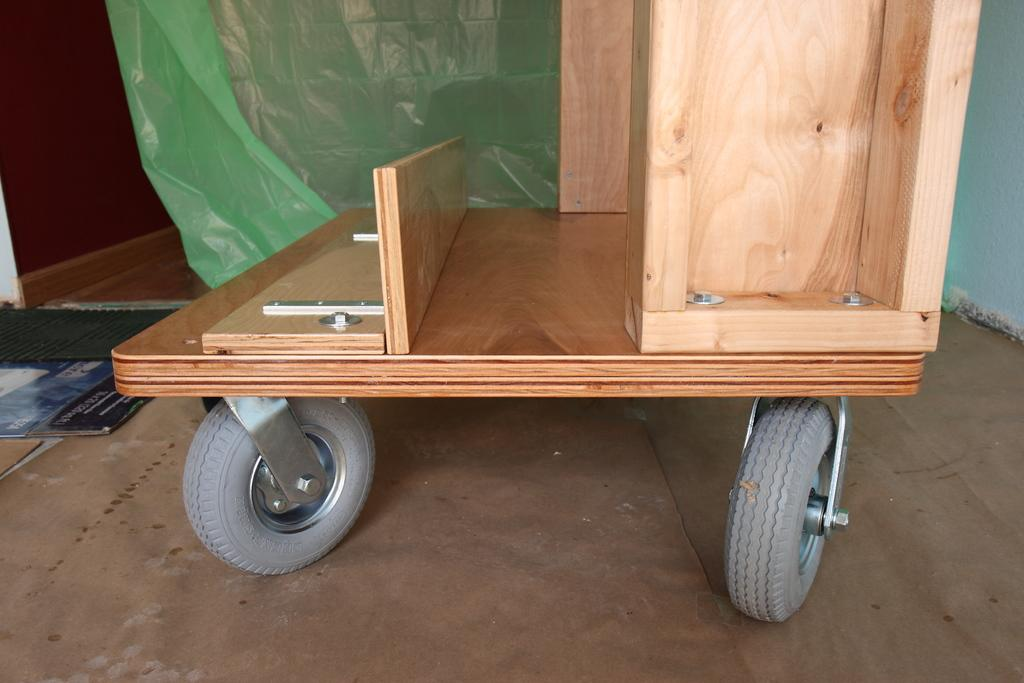What type of object is in the foreground of the image? There is a wooden trolley in the image. What can be seen in the background of the image? There is a green cover in the background of the image. What color is the wall in the background? The wall in the background is blue. Can you see a plane flying over the garden in the image? There is no plane or garden present in the image. Is there a knife being used to cut something on the wooden trolley? There is no knife visible in the image. 